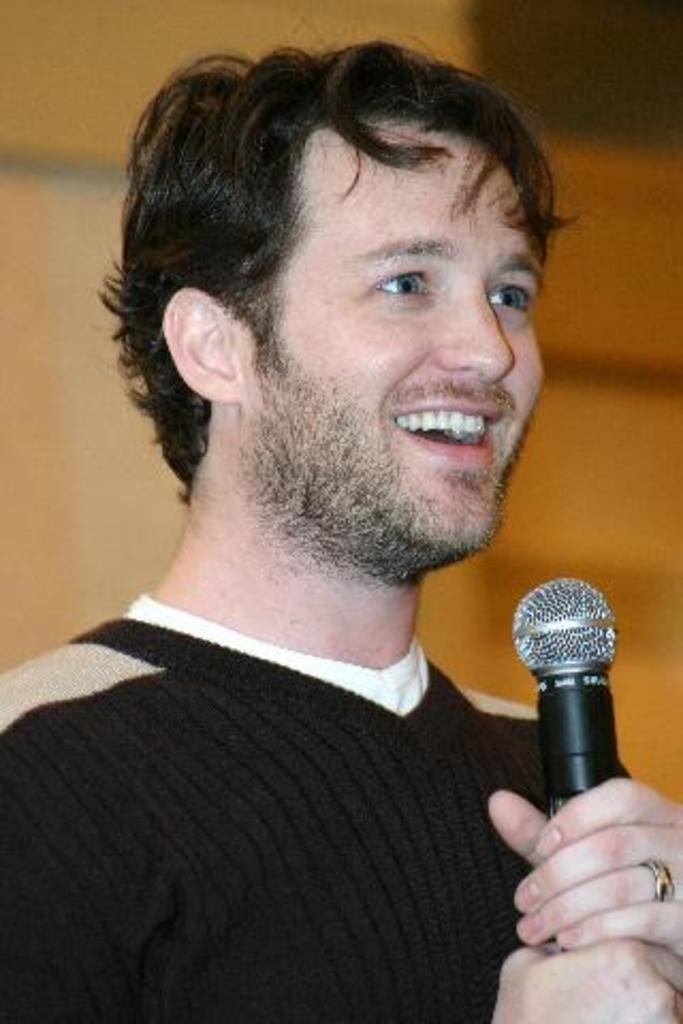What is the main subject of the image? There is a person in the image. What is the person wearing? The person is wearing a black T-shirt. What is the person holding in their hands? The person is holding a mic in their hands. What expression does the person have? The person is smiling. How would you describe the background of the image? The background of the image is slightly blurred. What type of underwear is the person wearing in the image? There is no information about the person's underwear in the image, so we cannot determine what type they are wearing. 